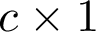<formula> <loc_0><loc_0><loc_500><loc_500>c \times 1</formula> 